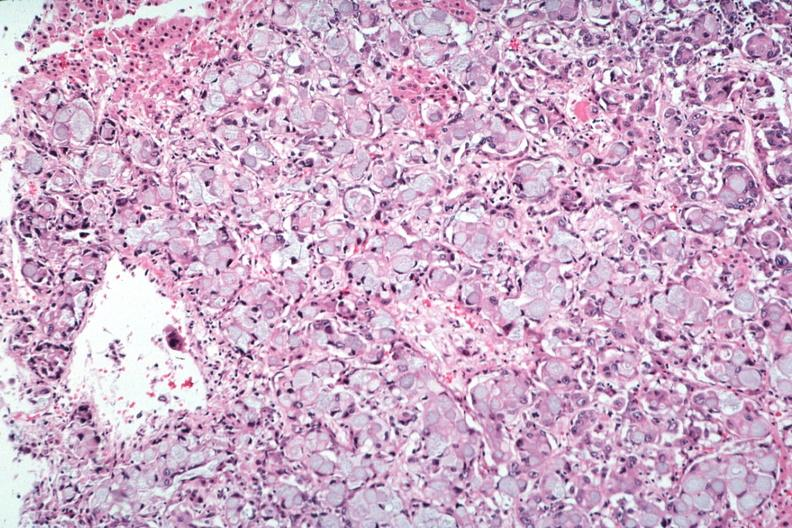s adrenal present?
Answer the question using a single word or phrase. Yes 